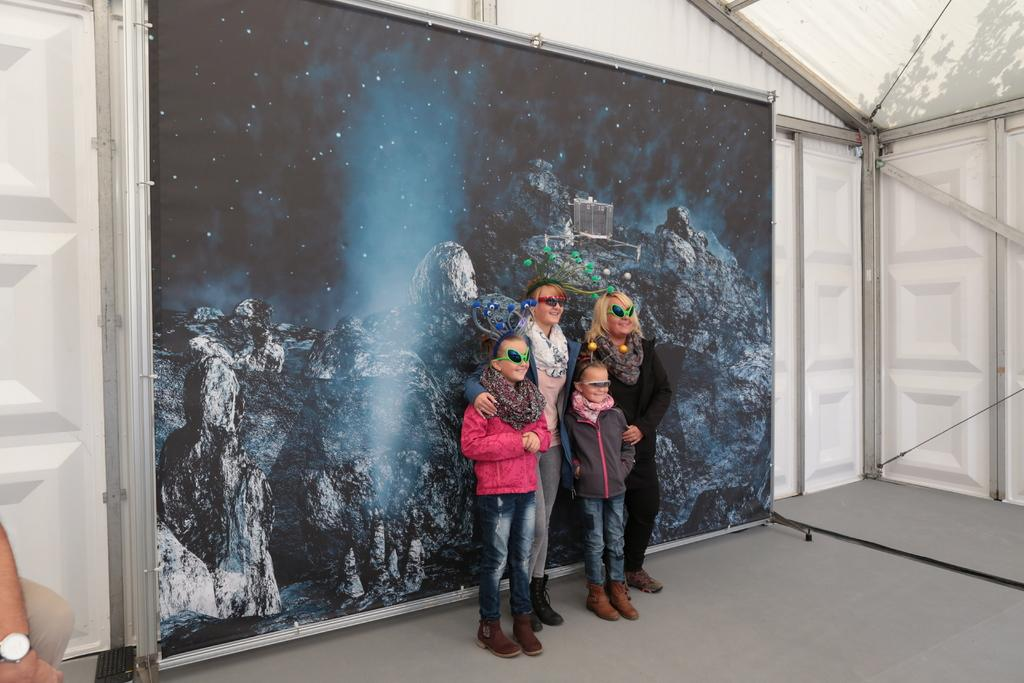What can be seen in the image? There are people standing in the image. Where are the people standing? The people are standing on the floor. What is visible in the background of the image? There is a board with a painting in the background. How many doors can be seen in the image? There are doors on both sides of the image. What type of apparel is the person wearing in the image? There is no specific apparel mentioned in the provided facts, so it cannot be determined from the image. 